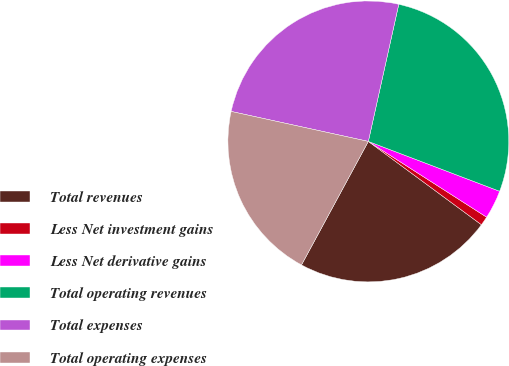<chart> <loc_0><loc_0><loc_500><loc_500><pie_chart><fcel>Total revenues<fcel>Less Net investment gains<fcel>Less Net derivative gains<fcel>Total operating revenues<fcel>Total expenses<fcel>Total operating expenses<nl><fcel>22.79%<fcel>1.04%<fcel>3.29%<fcel>27.3%<fcel>25.05%<fcel>20.53%<nl></chart> 